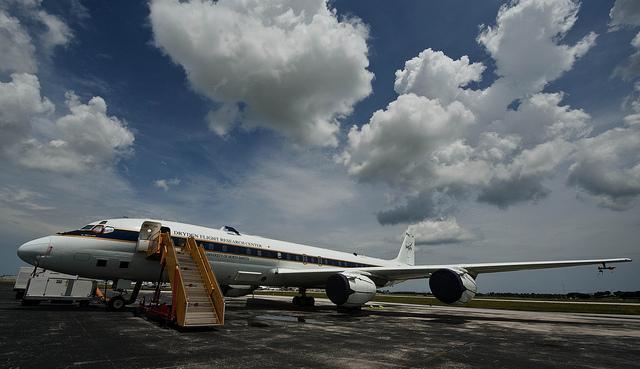How many propellers does this plane have?
Give a very brief answer. 0. How many buses are solid blue?
Give a very brief answer. 0. 